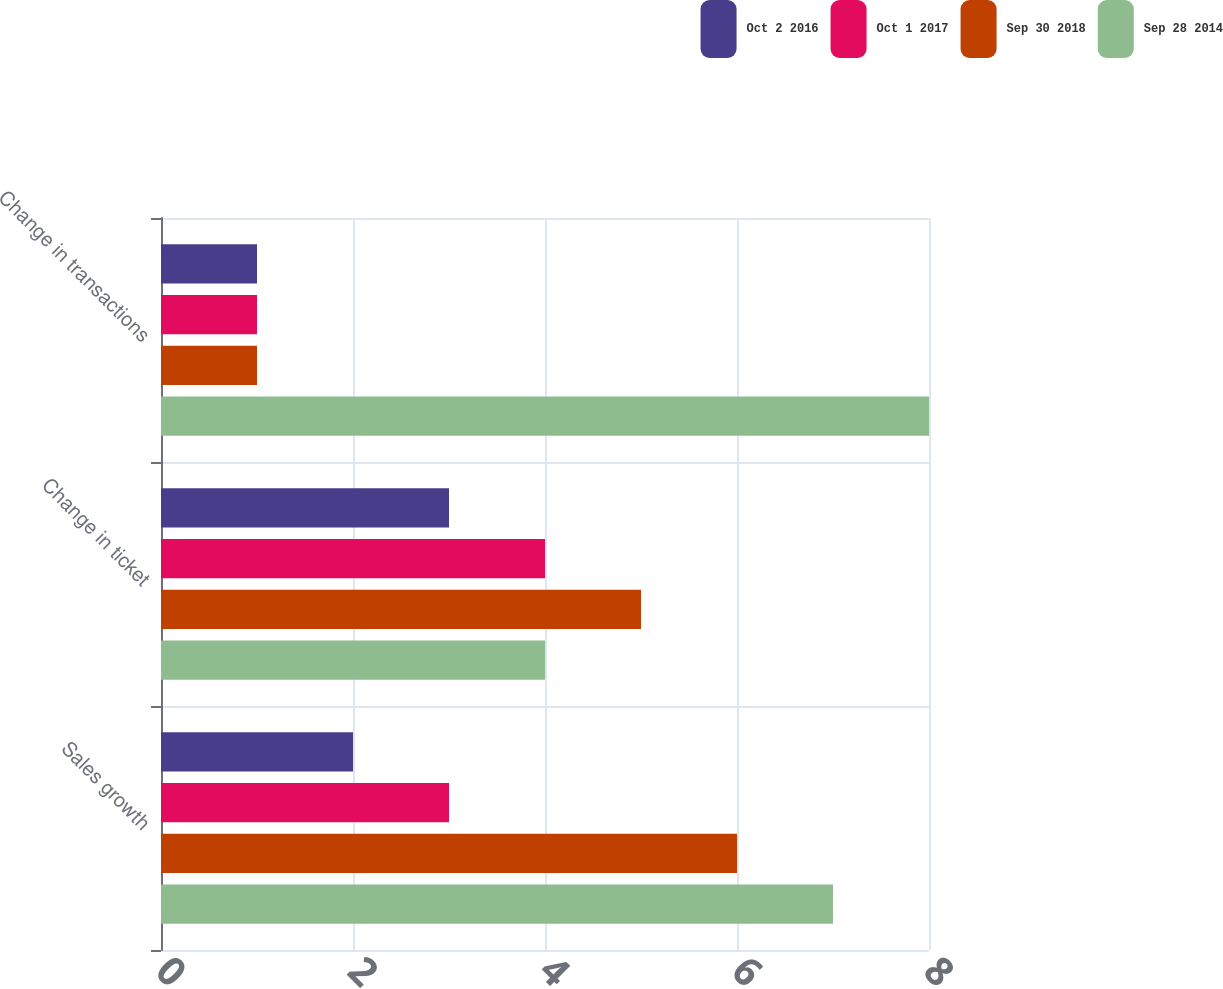Convert chart. <chart><loc_0><loc_0><loc_500><loc_500><stacked_bar_chart><ecel><fcel>Sales growth<fcel>Change in ticket<fcel>Change in transactions<nl><fcel>Oct 2 2016<fcel>2<fcel>3<fcel>1<nl><fcel>Oct 1 2017<fcel>3<fcel>4<fcel>1<nl><fcel>Sep 30 2018<fcel>6<fcel>5<fcel>1<nl><fcel>Sep 28 2014<fcel>7<fcel>4<fcel>8<nl></chart> 